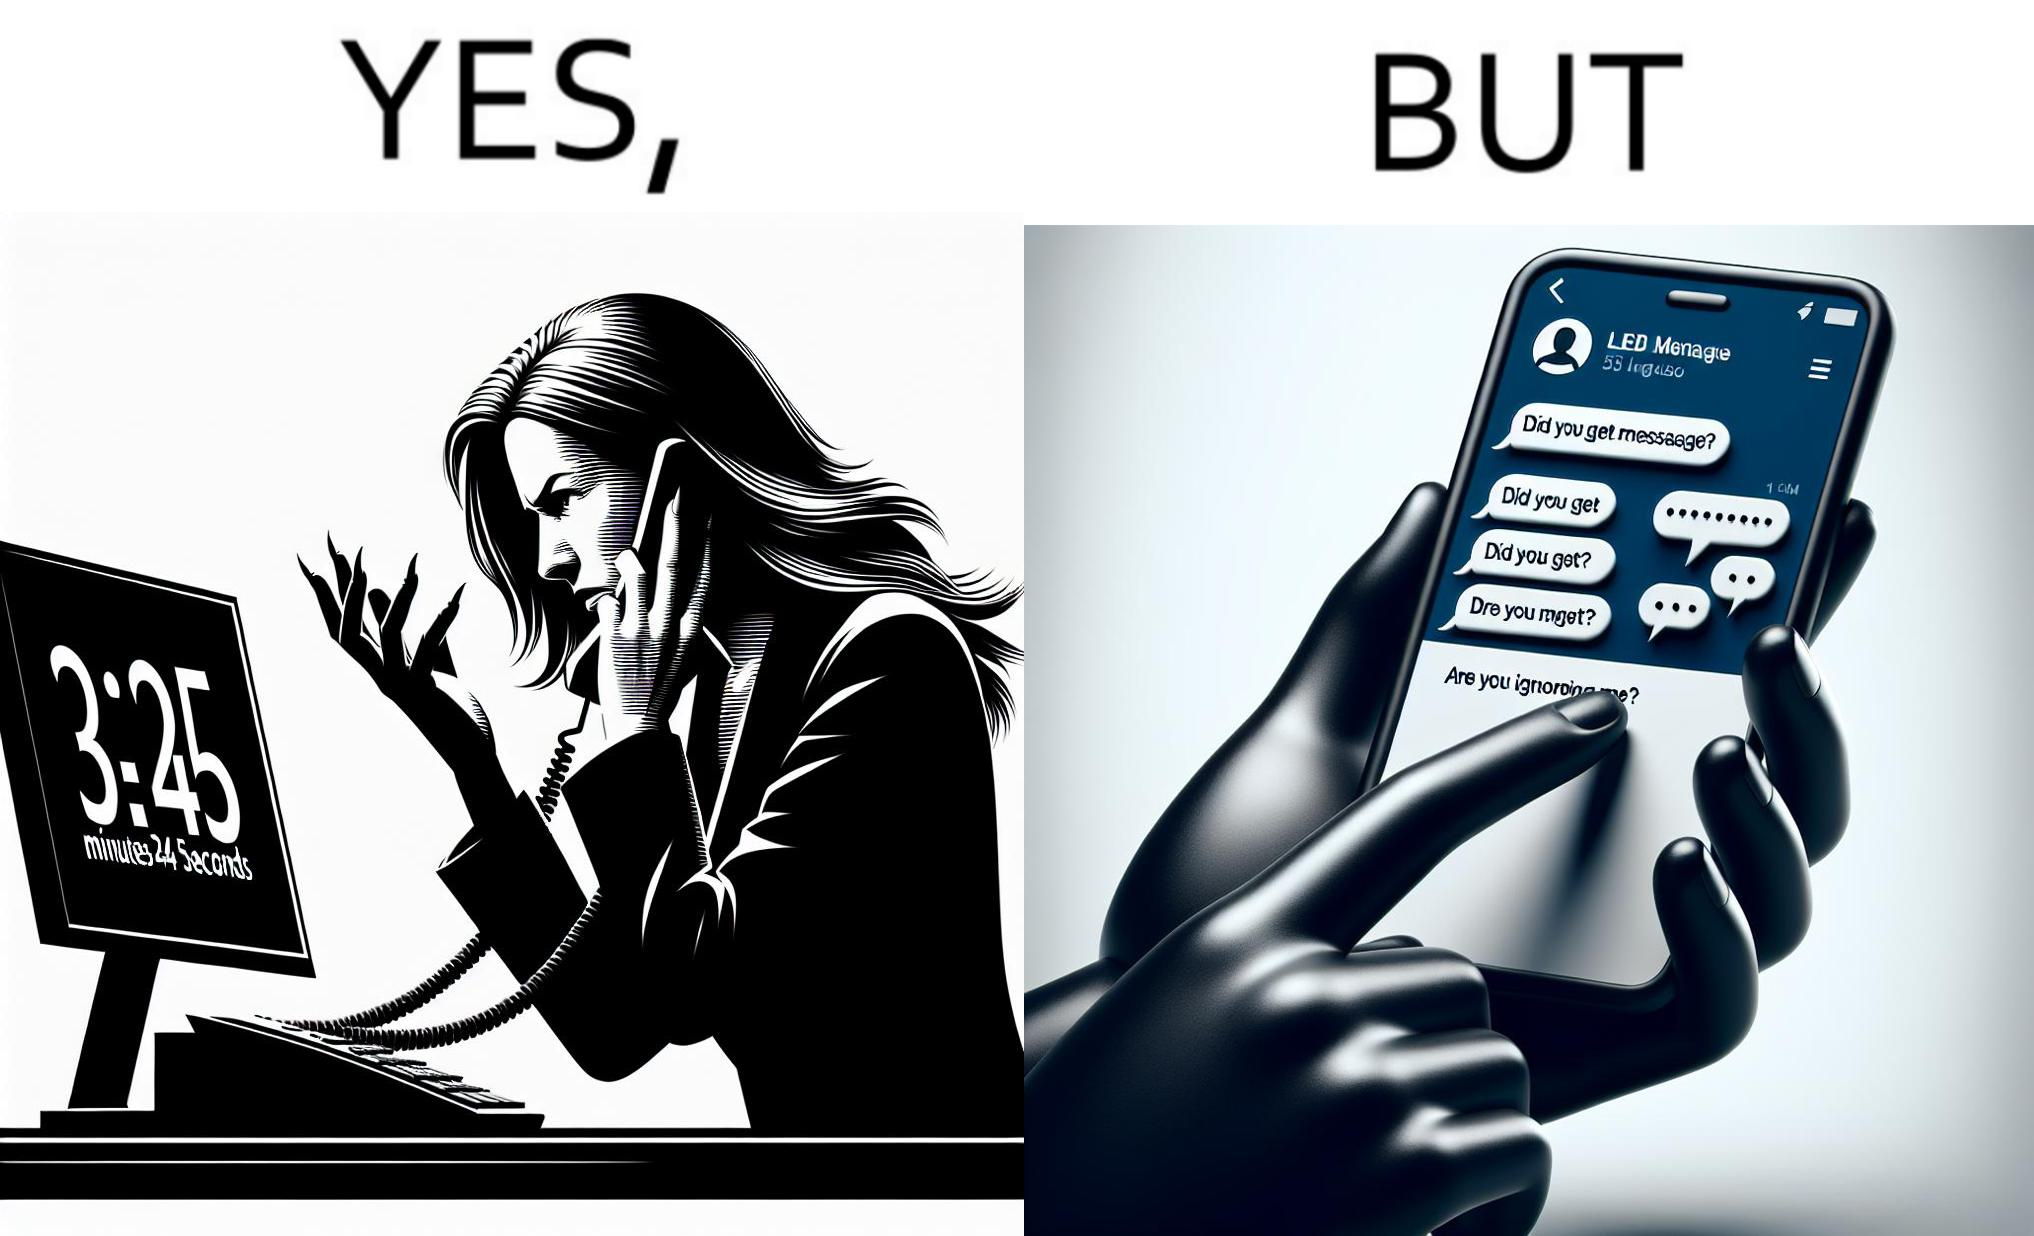Describe the satirical element in this image. The image is ironical because while the woman is annoyed by the unresponsiveness of the call center, she herself is being unresponsive to many people in the chat. 